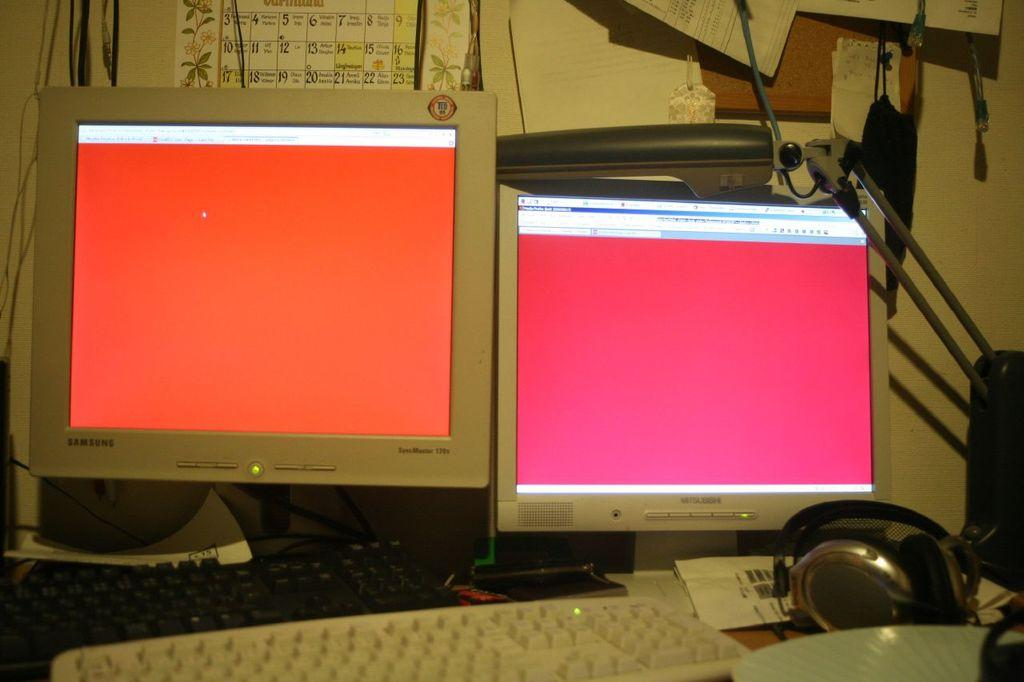<image>
Relay a brief, clear account of the picture shown. Two computer monitors next to one another one is a Samsung and the other Mitsubishi both with pink screens. 